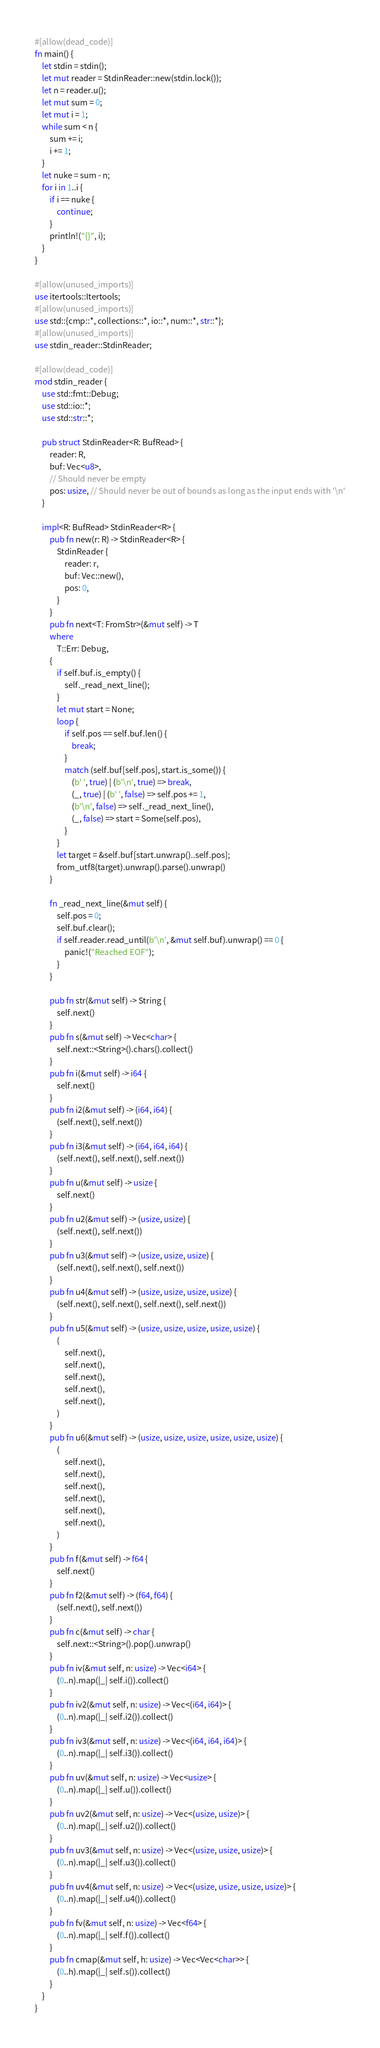<code> <loc_0><loc_0><loc_500><loc_500><_Rust_>#[allow(dead_code)]
fn main() {
    let stdin = stdin();
    let mut reader = StdinReader::new(stdin.lock());
    let n = reader.u();
    let mut sum = 0;
    let mut i = 1;
    while sum < n {
        sum += i;
        i += 1;
    }
    let nuke = sum - n;
    for i in 1..i {
        if i == nuke {
            continue;
        }
        println!("{}", i);
    }
}

#[allow(unused_imports)]
use itertools::Itertools;
#[allow(unused_imports)]
use std::{cmp::*, collections::*, io::*, num::*, str::*};
#[allow(unused_imports)]
use stdin_reader::StdinReader;

#[allow(dead_code)]
mod stdin_reader {
    use std::fmt::Debug;
    use std::io::*;
    use std::str::*;

    pub struct StdinReader<R: BufRead> {
        reader: R,
        buf: Vec<u8>,
        // Should never be empty
        pos: usize, // Should never be out of bounds as long as the input ends with '\n'
    }

    impl<R: BufRead> StdinReader<R> {
        pub fn new(r: R) -> StdinReader<R> {
            StdinReader {
                reader: r,
                buf: Vec::new(),
                pos: 0,
            }
        }
        pub fn next<T: FromStr>(&mut self) -> T
        where
            T::Err: Debug,
        {
            if self.buf.is_empty() {
                self._read_next_line();
            }
            let mut start = None;
            loop {
                if self.pos == self.buf.len() {
                    break;
                }
                match (self.buf[self.pos], start.is_some()) {
                    (b' ', true) | (b'\n', true) => break,
                    (_, true) | (b' ', false) => self.pos += 1,
                    (b'\n', false) => self._read_next_line(),
                    (_, false) => start = Some(self.pos),
                }
            }
            let target = &self.buf[start.unwrap()..self.pos];
            from_utf8(target).unwrap().parse().unwrap()
        }

        fn _read_next_line(&mut self) {
            self.pos = 0;
            self.buf.clear();
            if self.reader.read_until(b'\n', &mut self.buf).unwrap() == 0 {
                panic!("Reached EOF");
            }
        }

        pub fn str(&mut self) -> String {
            self.next()
        }
        pub fn s(&mut self) -> Vec<char> {
            self.next::<String>().chars().collect()
        }
        pub fn i(&mut self) -> i64 {
            self.next()
        }
        pub fn i2(&mut self) -> (i64, i64) {
            (self.next(), self.next())
        }
        pub fn i3(&mut self) -> (i64, i64, i64) {
            (self.next(), self.next(), self.next())
        }
        pub fn u(&mut self) -> usize {
            self.next()
        }
        pub fn u2(&mut self) -> (usize, usize) {
            (self.next(), self.next())
        }
        pub fn u3(&mut self) -> (usize, usize, usize) {
            (self.next(), self.next(), self.next())
        }
        pub fn u4(&mut self) -> (usize, usize, usize, usize) {
            (self.next(), self.next(), self.next(), self.next())
        }
        pub fn u5(&mut self) -> (usize, usize, usize, usize, usize) {
            (
                self.next(),
                self.next(),
                self.next(),
                self.next(),
                self.next(),
            )
        }
        pub fn u6(&mut self) -> (usize, usize, usize, usize, usize, usize) {
            (
                self.next(),
                self.next(),
                self.next(),
                self.next(),
                self.next(),
                self.next(),
            )
        }
        pub fn f(&mut self) -> f64 {
            self.next()
        }
        pub fn f2(&mut self) -> (f64, f64) {
            (self.next(), self.next())
        }
        pub fn c(&mut self) -> char {
            self.next::<String>().pop().unwrap()
        }
        pub fn iv(&mut self, n: usize) -> Vec<i64> {
            (0..n).map(|_| self.i()).collect()
        }
        pub fn iv2(&mut self, n: usize) -> Vec<(i64, i64)> {
            (0..n).map(|_| self.i2()).collect()
        }
        pub fn iv3(&mut self, n: usize) -> Vec<(i64, i64, i64)> {
            (0..n).map(|_| self.i3()).collect()
        }
        pub fn uv(&mut self, n: usize) -> Vec<usize> {
            (0..n).map(|_| self.u()).collect()
        }
        pub fn uv2(&mut self, n: usize) -> Vec<(usize, usize)> {
            (0..n).map(|_| self.u2()).collect()
        }
        pub fn uv3(&mut self, n: usize) -> Vec<(usize, usize, usize)> {
            (0..n).map(|_| self.u3()).collect()
        }
        pub fn uv4(&mut self, n: usize) -> Vec<(usize, usize, usize, usize)> {
            (0..n).map(|_| self.u4()).collect()
        }
        pub fn fv(&mut self, n: usize) -> Vec<f64> {
            (0..n).map(|_| self.f()).collect()
        }
        pub fn cmap(&mut self, h: usize) -> Vec<Vec<char>> {
            (0..h).map(|_| self.s()).collect()
        }
    }
}
</code> 